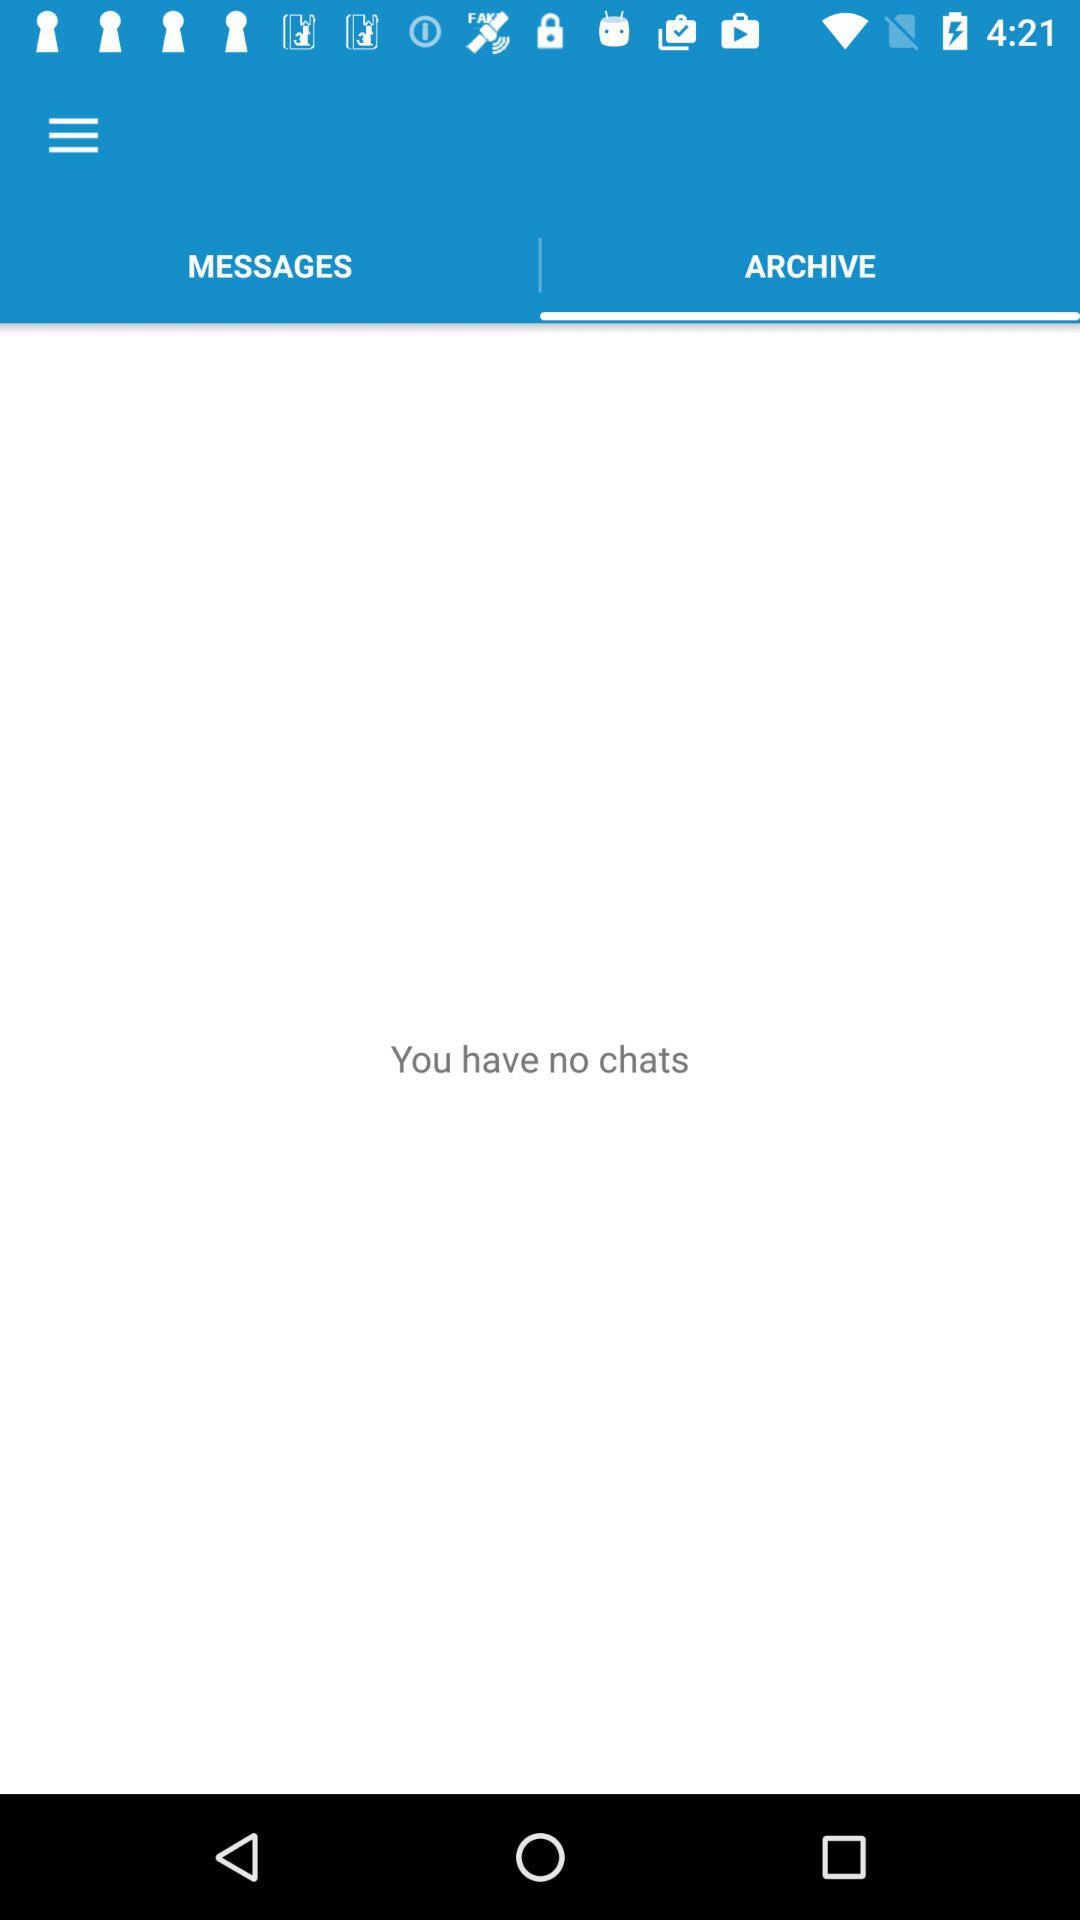How many messages are there?
When the provided information is insufficient, respond with <no answer>. <no answer> 